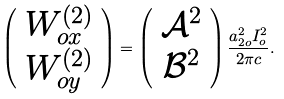<formula> <loc_0><loc_0><loc_500><loc_500>\left ( \begin{array} { c } { W } _ { o x } ^ { ( 2 ) } \\ { W } _ { o y } ^ { ( 2 ) } \end{array} \right ) = \left ( \begin{array} { c } \mathcal { A } ^ { 2 } \\ \mathcal { B } ^ { 2 } \end{array} \right ) \frac { a _ { 2 o } ^ { 2 } I _ { o } ^ { 2 } } { 2 \pi c } .</formula> 